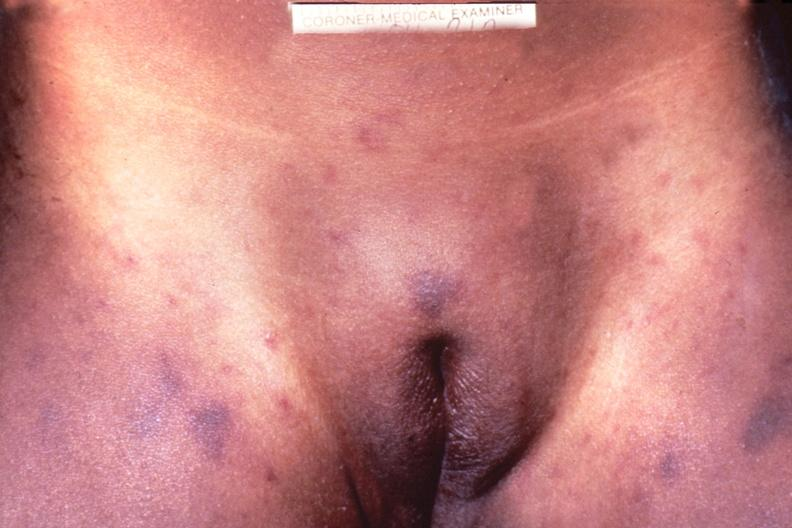does this image show meningococcemia, petechia?
Answer the question using a single word or phrase. Yes 